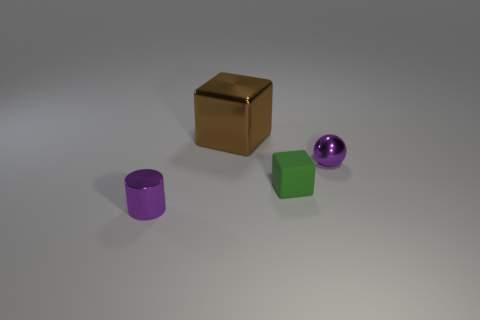Is there anything else that has the same material as the tiny green thing?
Offer a terse response. No. There is a purple cylinder; does it have the same size as the metallic object that is to the right of the green matte cube?
Make the answer very short. Yes. Is the number of metal spheres left of the big brown block the same as the number of metal balls on the right side of the tiny purple shiny sphere?
Ensure brevity in your answer.  Yes. What is the shape of the small object that is the same color as the tiny sphere?
Offer a terse response. Cylinder. What material is the block in front of the tiny metallic sphere?
Offer a very short reply. Rubber. Do the rubber thing and the shiny ball have the same size?
Ensure brevity in your answer.  Yes. Is the number of tiny purple metallic objects right of the large metal object greater than the number of large cyan cylinders?
Ensure brevity in your answer.  Yes. There is a brown block that is the same material as the small purple cylinder; what size is it?
Ensure brevity in your answer.  Large. Are there any tiny shiny objects to the left of the matte cube?
Keep it short and to the point. Yes. Is the big metallic thing the same shape as the tiny green object?
Ensure brevity in your answer.  Yes. 